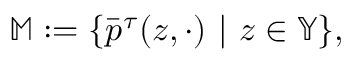<formula> <loc_0><loc_0><loc_500><loc_500>\mathbb { M } \colon = \{ \bar { p } ^ { \tau } ( z , \cdot ) | z \in \mathbb { Y } \} ,</formula> 